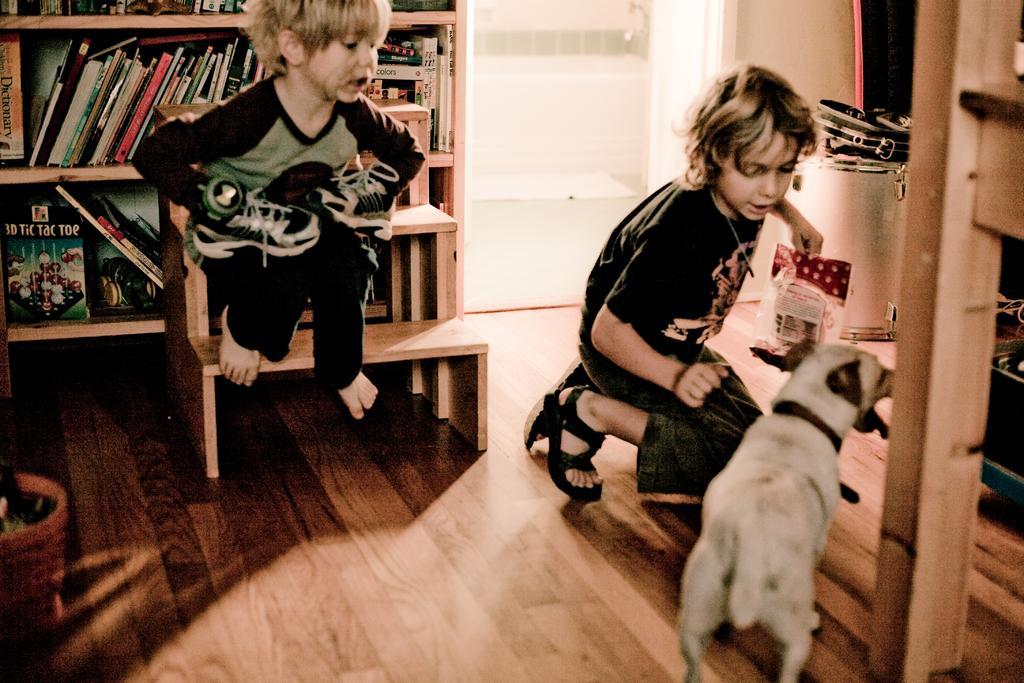Can you describe this image briefly? In this image I can see two children. There are books in shelves. There is a dog and there are some other objects. 